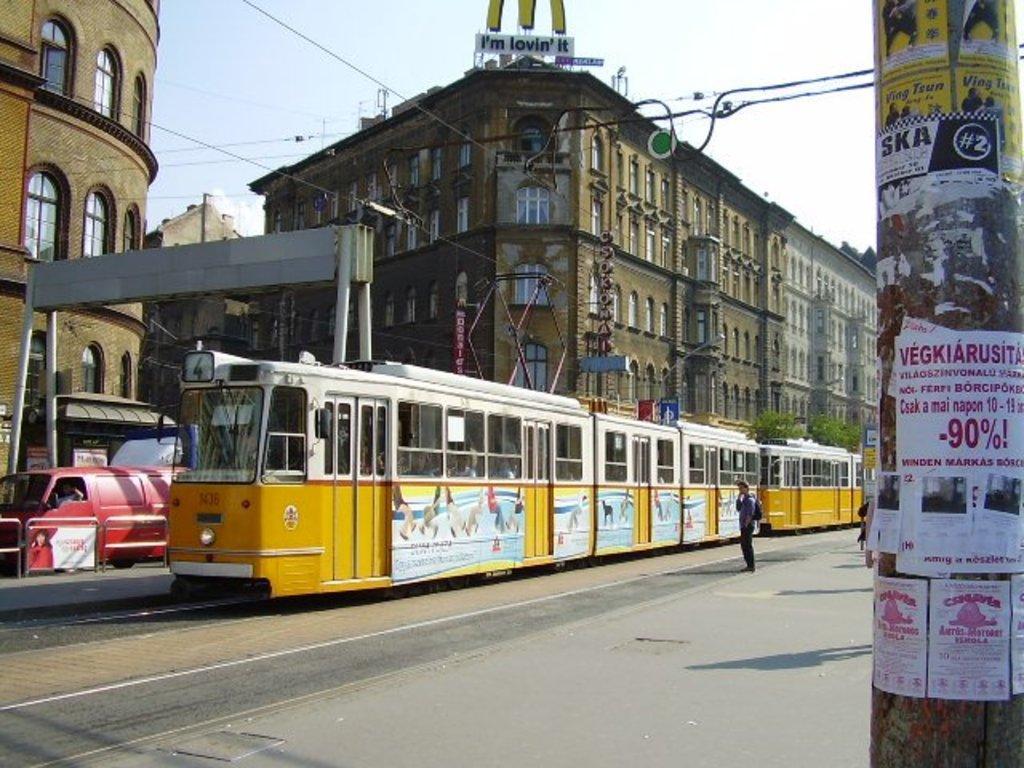Please provide a concise description of this image. In this image there is a street running train on road, near to the train there is a person standing, in the background there are buildings, hoarding, vehicles, on the right side there is a pole to that pole there are posters, on that posters there is some text. 